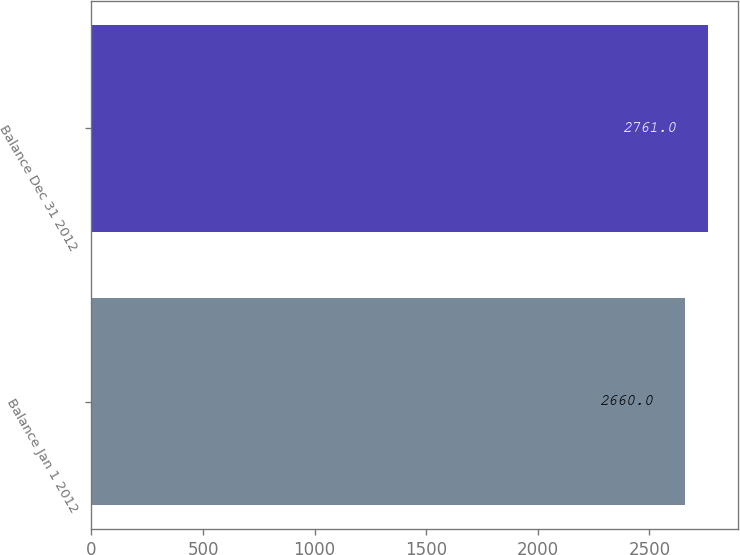Convert chart. <chart><loc_0><loc_0><loc_500><loc_500><bar_chart><fcel>Balance Jan 1 2012<fcel>Balance Dec 31 2012<nl><fcel>2660<fcel>2761<nl></chart> 